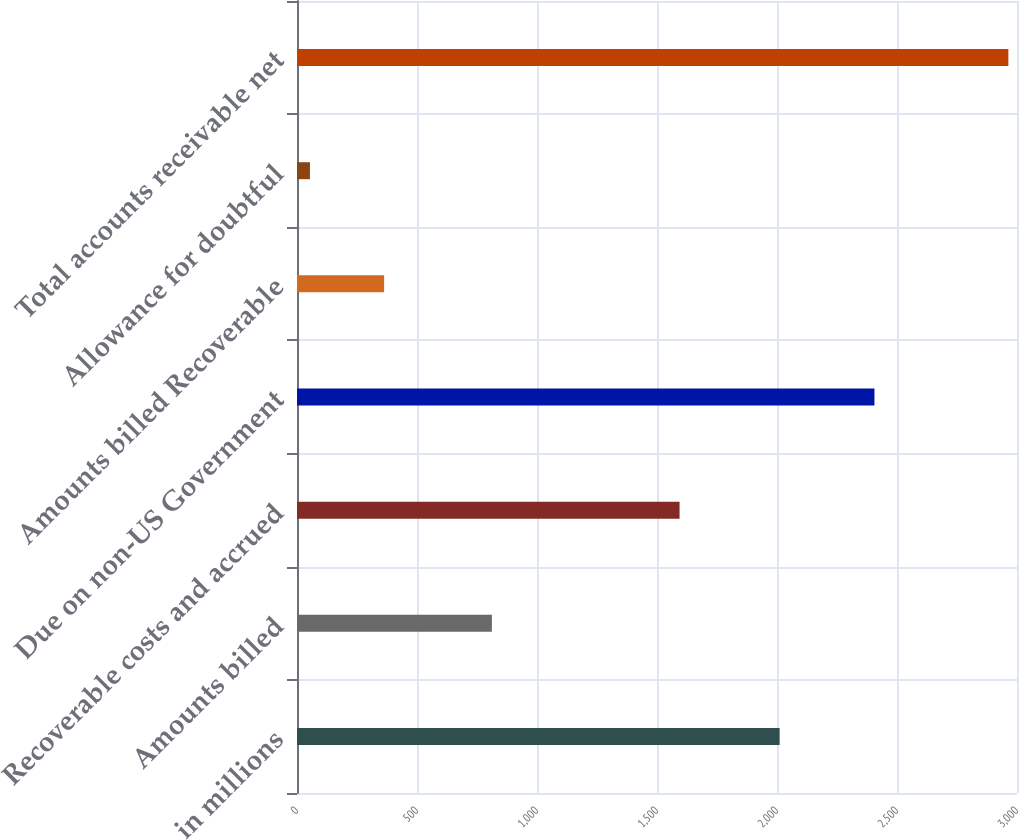Convert chart to OTSL. <chart><loc_0><loc_0><loc_500><loc_500><bar_chart><fcel>in millions<fcel>Amounts billed<fcel>Recoverable costs and accrued<fcel>Due on non-US Government<fcel>Amounts billed Recoverable<fcel>Allowance for doubtful<fcel>Total accounts receivable net<nl><fcel>2011<fcel>812<fcel>1594<fcel>2406<fcel>363<fcel>54<fcel>2964<nl></chart> 